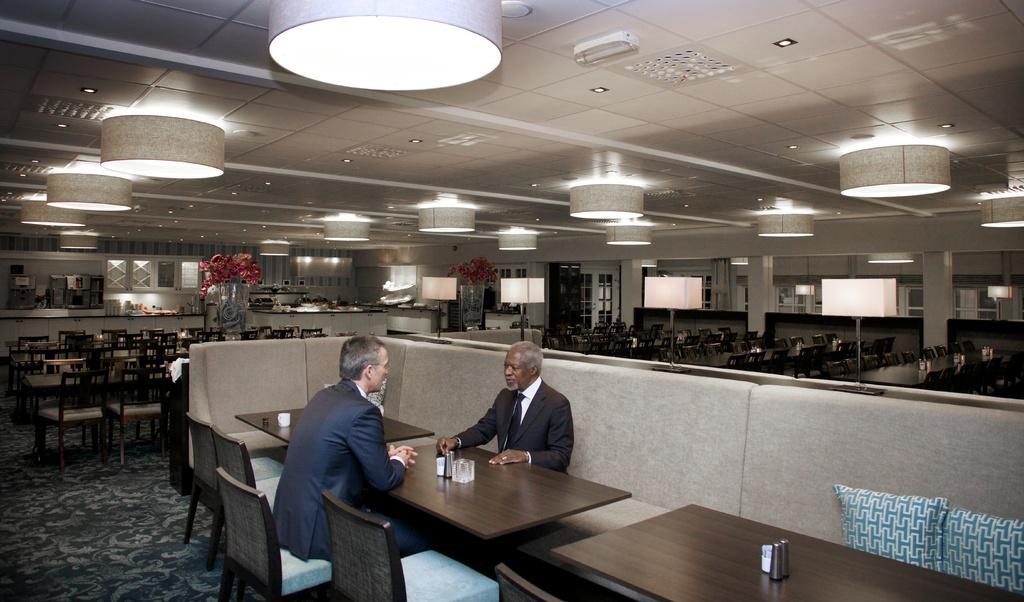In one or two sentences, can you explain what this image depicts? This is a picture of restaurant. This is a ceiling and lights. We can see flower vases, lot many empty chairs and tables. We can see two men sitting on chairs, opposite to each of them. This is a floor. 